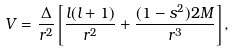<formula> <loc_0><loc_0><loc_500><loc_500>V = \frac { \Delta } { r ^ { 2 } } \left [ \frac { l ( l + 1 ) } { r ^ { 2 } } + \frac { ( 1 - s ^ { 2 } ) 2 M } { r ^ { 3 } } \right ] ,</formula> 